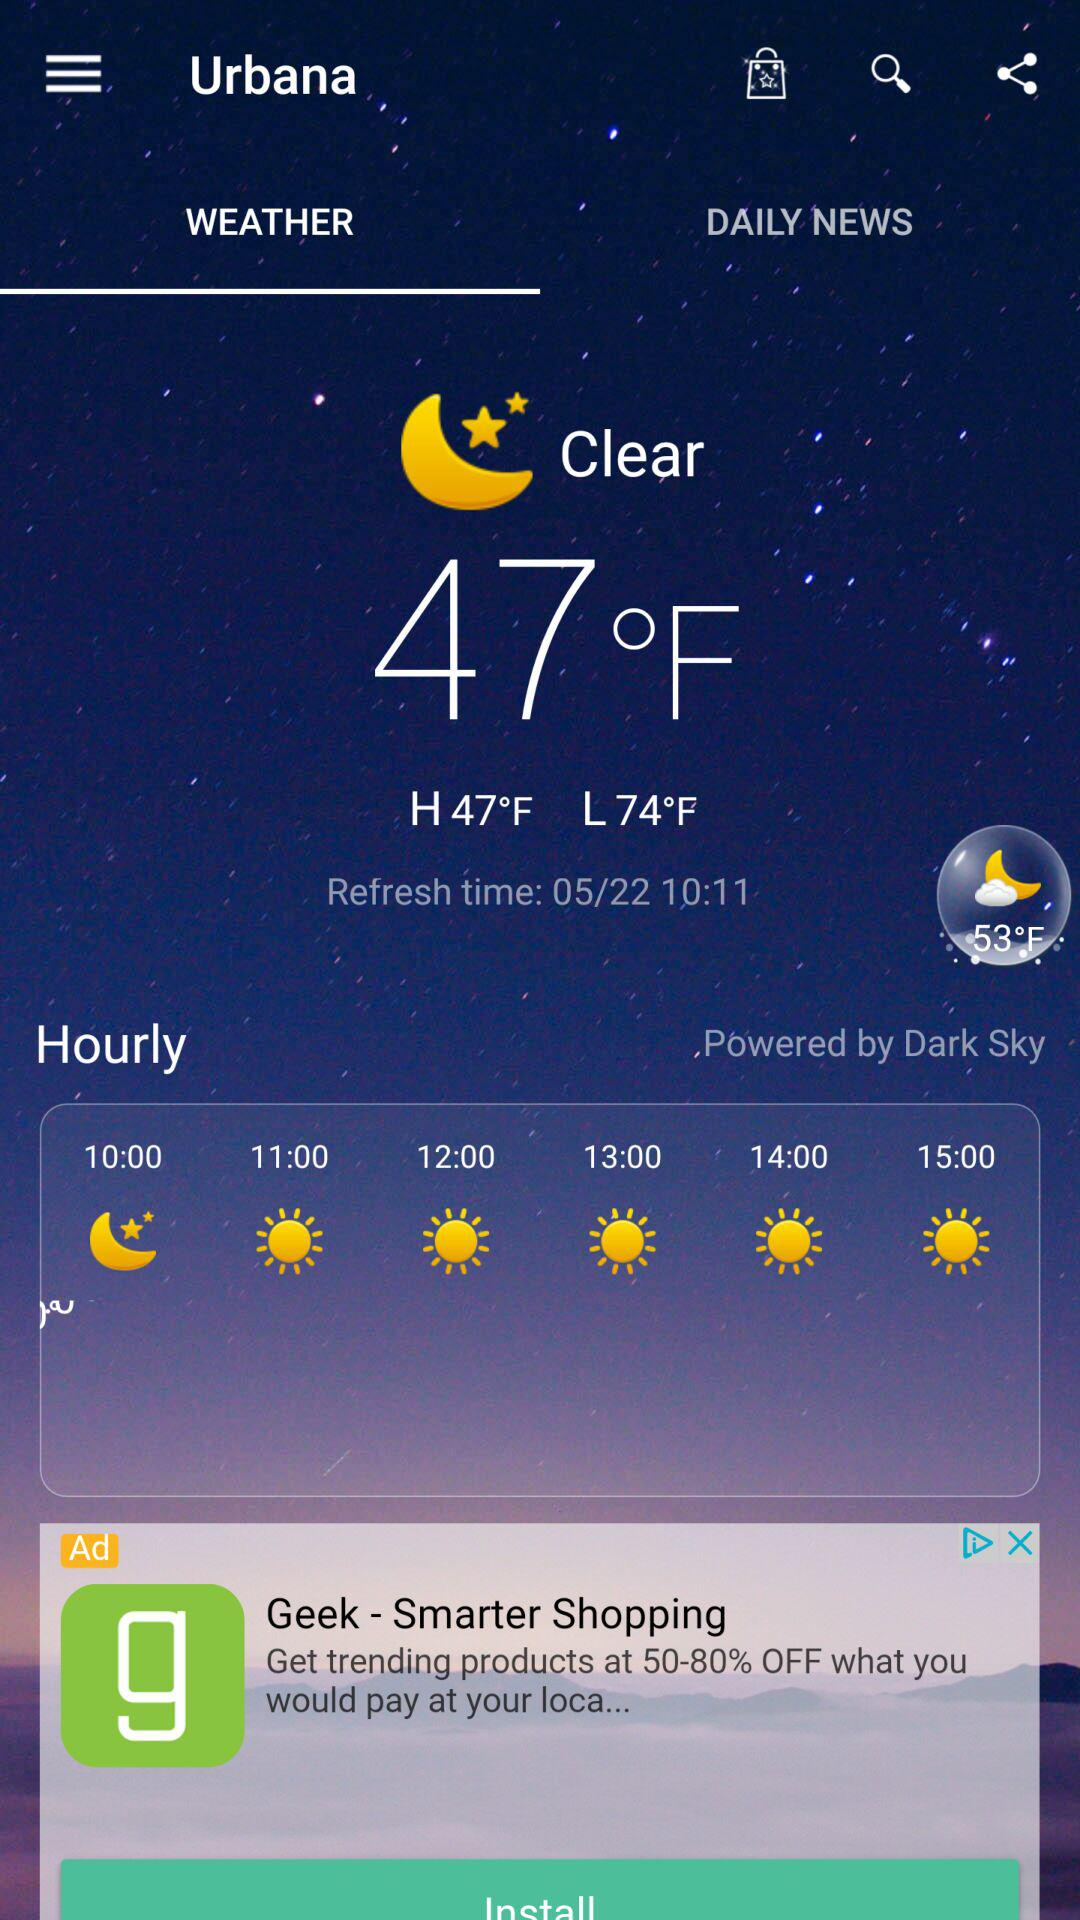How many degrees Fahrenheit is the high temperature?
Answer the question using a single word or phrase. 47°F 